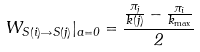Convert formula to latex. <formula><loc_0><loc_0><loc_500><loc_500>W _ { S ( i ) \rightarrow S ( j ) } | _ { a = 0 } = \frac { \frac { \pi _ { j } } { k ( j ) } - \frac { \pi _ { i } } { k _ { \max } } } { 2 }</formula> 